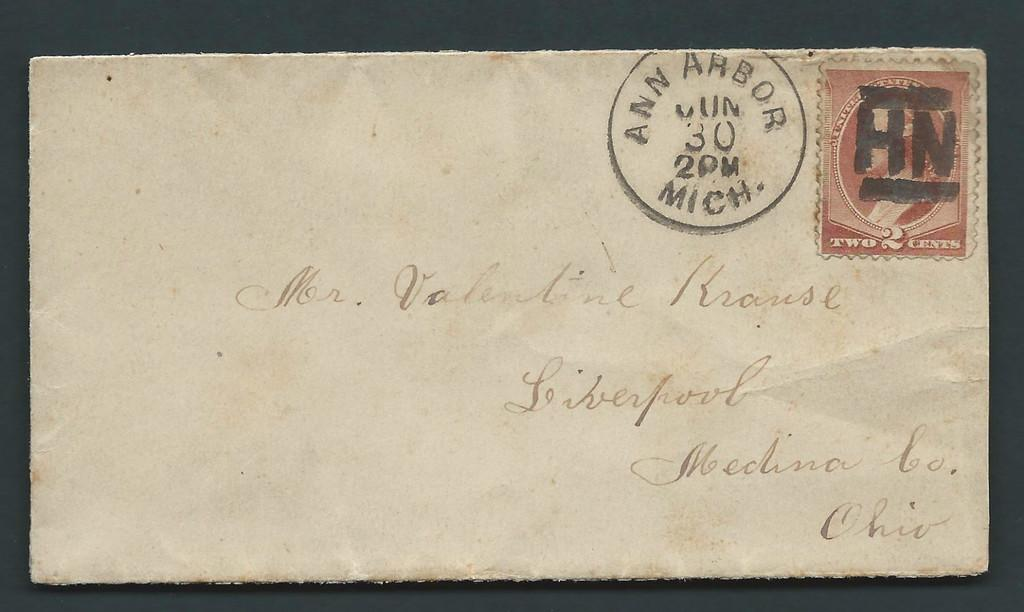Provide a one-sentence caption for the provided image. A very old envelope postmarked Ann Arbor, Michigan. 